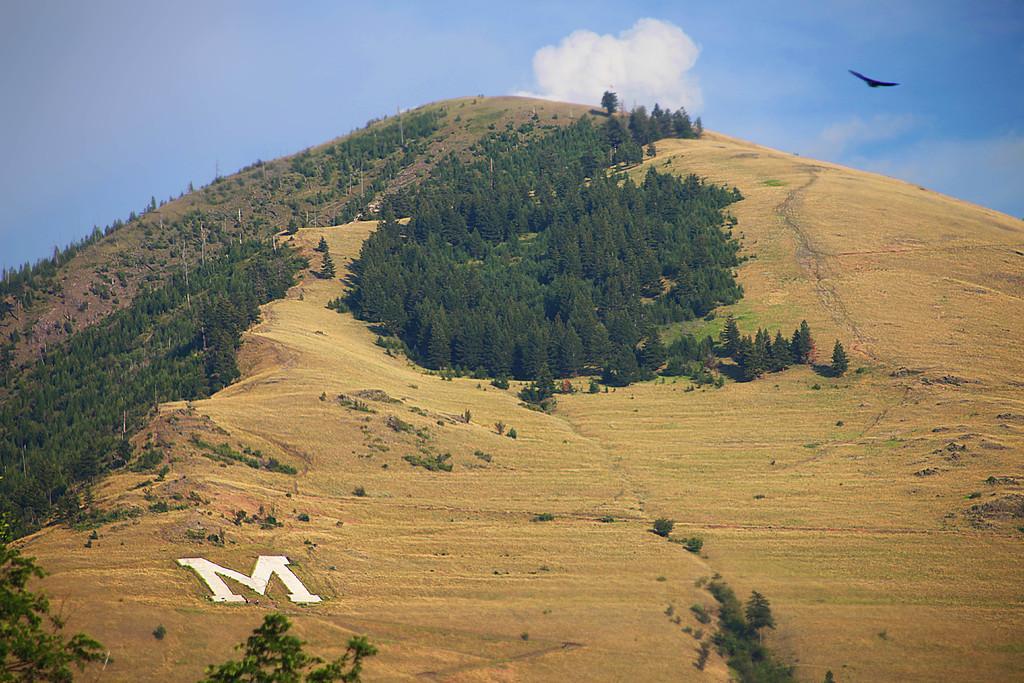How would you summarize this image in a sentence or two? We can see alphabet on the surface,trees,hill and grass. In the background we can see bird in the air and sky with clouds. 